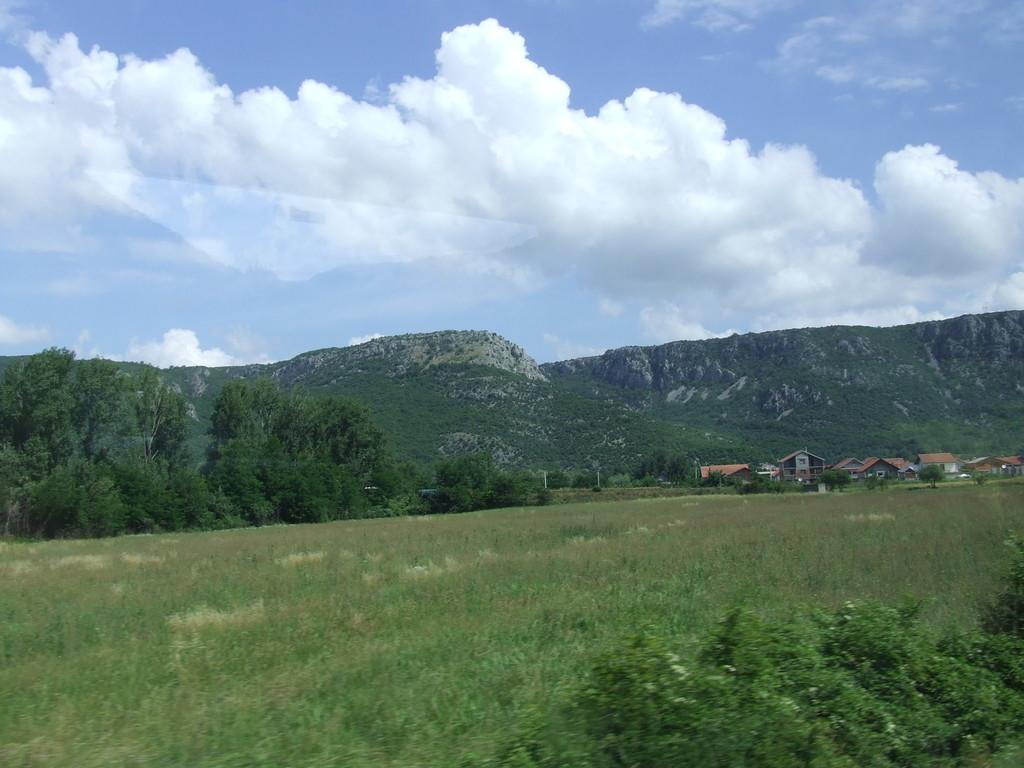What type of terrain is visible in the foreground of the image? There is grassland in the foreground of the image. What other natural elements can be seen in the image? There are trees in the image. Are there any man-made structures visible? Yes, there are houses in the image. What can be seen in the background of the image? It appears there are mountains in the background of the image, and the sky is also visible. What year is depicted in the image? The image does not depict a specific year; it is a photograph of a landscape. Can you see any toads in the image? There are no toads visible in the image. 